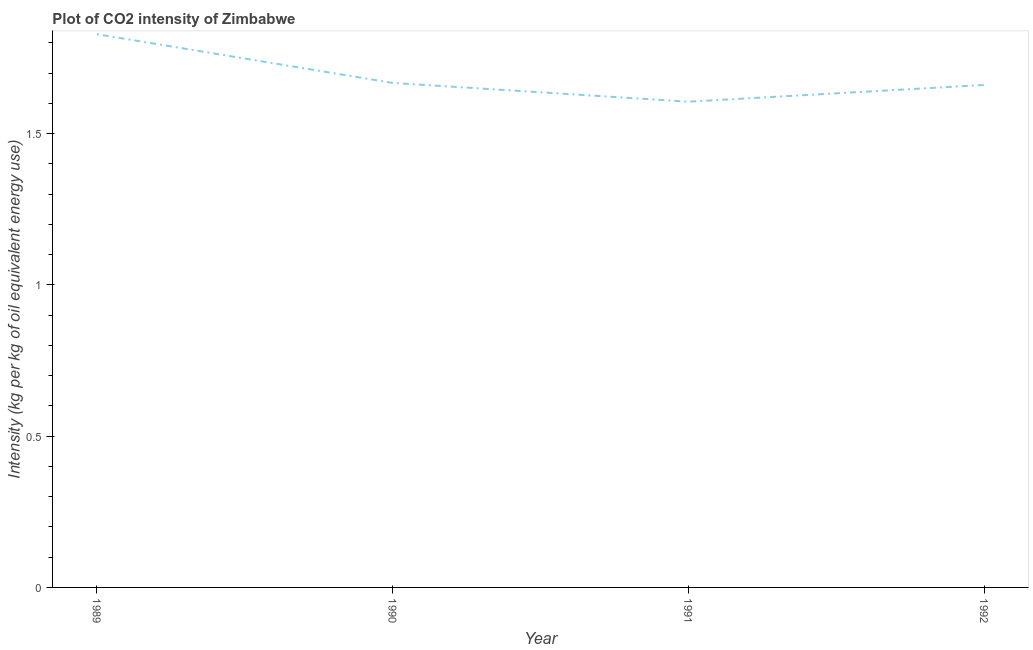What is the co2 intensity in 1989?
Make the answer very short. 1.83. Across all years, what is the maximum co2 intensity?
Offer a terse response. 1.83. Across all years, what is the minimum co2 intensity?
Provide a succinct answer. 1.61. In which year was the co2 intensity maximum?
Give a very brief answer. 1989. What is the sum of the co2 intensity?
Give a very brief answer. 6.76. What is the difference between the co2 intensity in 1991 and 1992?
Provide a succinct answer. -0.06. What is the average co2 intensity per year?
Provide a short and direct response. 1.69. What is the median co2 intensity?
Make the answer very short. 1.66. What is the ratio of the co2 intensity in 1990 to that in 1992?
Your response must be concise. 1. Is the difference between the co2 intensity in 1989 and 1992 greater than the difference between any two years?
Offer a very short reply. No. What is the difference between the highest and the second highest co2 intensity?
Give a very brief answer. 0.16. Is the sum of the co2 intensity in 1989 and 1991 greater than the maximum co2 intensity across all years?
Your answer should be very brief. Yes. What is the difference between the highest and the lowest co2 intensity?
Make the answer very short. 0.22. In how many years, is the co2 intensity greater than the average co2 intensity taken over all years?
Offer a terse response. 1. How many years are there in the graph?
Provide a succinct answer. 4. Are the values on the major ticks of Y-axis written in scientific E-notation?
Offer a very short reply. No. Does the graph contain grids?
Your answer should be compact. No. What is the title of the graph?
Provide a succinct answer. Plot of CO2 intensity of Zimbabwe. What is the label or title of the X-axis?
Provide a short and direct response. Year. What is the label or title of the Y-axis?
Ensure brevity in your answer.  Intensity (kg per kg of oil equivalent energy use). What is the Intensity (kg per kg of oil equivalent energy use) in 1989?
Ensure brevity in your answer.  1.83. What is the Intensity (kg per kg of oil equivalent energy use) in 1990?
Make the answer very short. 1.67. What is the Intensity (kg per kg of oil equivalent energy use) in 1991?
Keep it short and to the point. 1.61. What is the Intensity (kg per kg of oil equivalent energy use) of 1992?
Offer a terse response. 1.66. What is the difference between the Intensity (kg per kg of oil equivalent energy use) in 1989 and 1990?
Your answer should be compact. 0.16. What is the difference between the Intensity (kg per kg of oil equivalent energy use) in 1989 and 1991?
Give a very brief answer. 0.22. What is the difference between the Intensity (kg per kg of oil equivalent energy use) in 1989 and 1992?
Provide a succinct answer. 0.17. What is the difference between the Intensity (kg per kg of oil equivalent energy use) in 1990 and 1991?
Make the answer very short. 0.06. What is the difference between the Intensity (kg per kg of oil equivalent energy use) in 1990 and 1992?
Give a very brief answer. 0.01. What is the difference between the Intensity (kg per kg of oil equivalent energy use) in 1991 and 1992?
Your response must be concise. -0.06. What is the ratio of the Intensity (kg per kg of oil equivalent energy use) in 1989 to that in 1990?
Give a very brief answer. 1.1. What is the ratio of the Intensity (kg per kg of oil equivalent energy use) in 1989 to that in 1991?
Offer a terse response. 1.14. What is the ratio of the Intensity (kg per kg of oil equivalent energy use) in 1989 to that in 1992?
Offer a terse response. 1.1. What is the ratio of the Intensity (kg per kg of oil equivalent energy use) in 1990 to that in 1991?
Give a very brief answer. 1.04. 